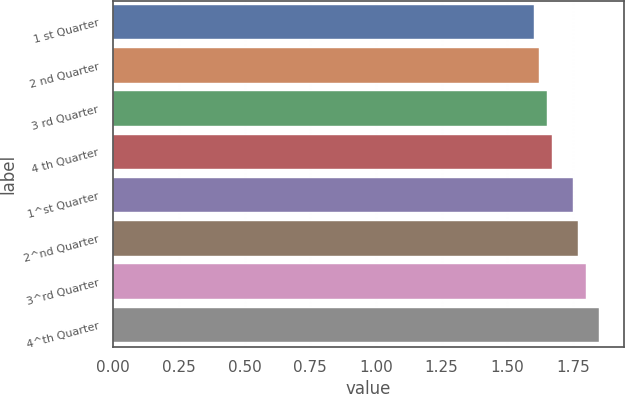<chart> <loc_0><loc_0><loc_500><loc_500><bar_chart><fcel>1 st Quarter<fcel>2 nd Quarter<fcel>3 rd Quarter<fcel>4 th Quarter<fcel>1^st Quarter<fcel>2^nd Quarter<fcel>3^rd Quarter<fcel>4^th Quarter<nl><fcel>1.6<fcel>1.62<fcel>1.65<fcel>1.67<fcel>1.75<fcel>1.77<fcel>1.8<fcel>1.85<nl></chart> 